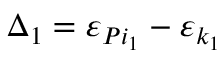Convert formula to latex. <formula><loc_0><loc_0><loc_500><loc_500>\Delta _ { 1 } = \varepsilon _ { P i _ { 1 } } - \varepsilon _ { k _ { 1 } }</formula> 